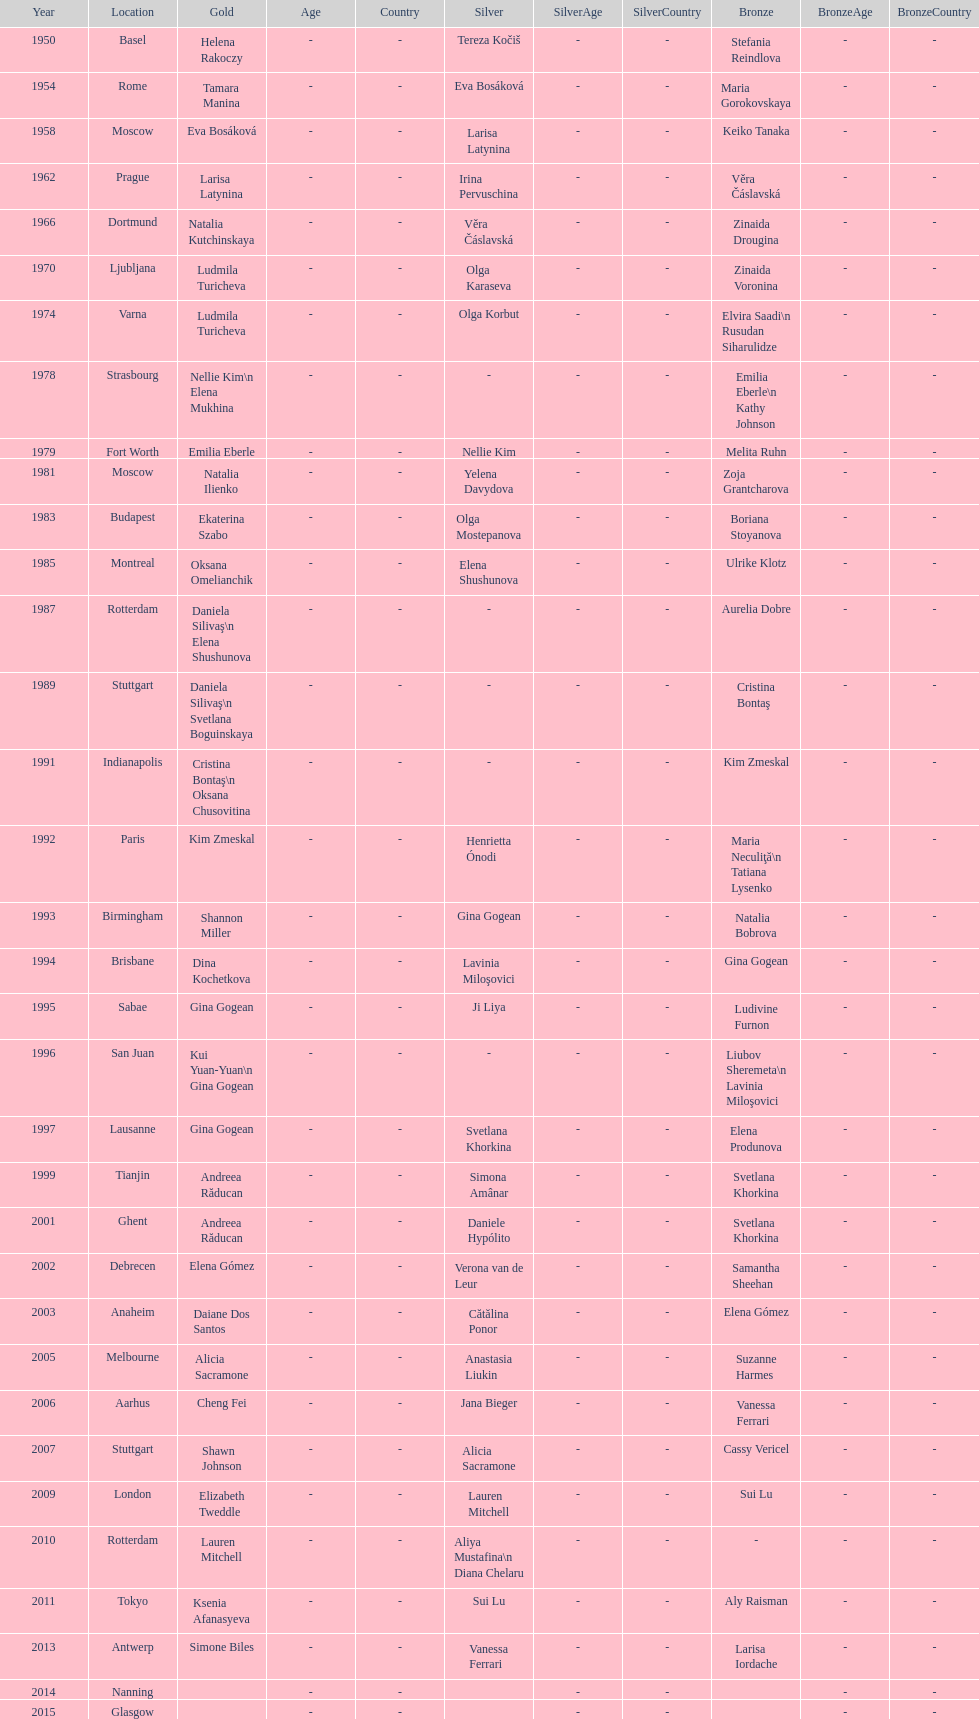Help me parse the entirety of this table. {'header': ['Year', 'Location', 'Gold', 'Age', 'Country', 'Silver', 'SilverAge', 'SilverCountry', 'Bronze', 'BronzeAge', 'BronzeCountry'], 'rows': [['1950', 'Basel', 'Helena Rakoczy', '-', '-', 'Tereza Kočiš', '-', '-', 'Stefania Reindlova', '-', '-'], ['1954', 'Rome', 'Tamara Manina', '-', '-', 'Eva Bosáková', '-', '-', 'Maria Gorokovskaya', '-', '-'], ['1958', 'Moscow', 'Eva Bosáková', '-', '-', 'Larisa Latynina', '-', '-', 'Keiko Tanaka', '-', '-'], ['1962', 'Prague', 'Larisa Latynina', '-', '-', 'Irina Pervuschina', '-', '-', 'Věra Čáslavská', '-', '-'], ['1966', 'Dortmund', 'Natalia Kutchinskaya', '-', '-', 'Věra Čáslavská', '-', '-', 'Zinaida Drougina', '-', '-'], ['1970', 'Ljubljana', 'Ludmila Turicheva', '-', '-', 'Olga Karaseva', '-', '-', 'Zinaida Voronina', '-', '-'], ['1974', 'Varna', 'Ludmila Turicheva', '-', '-', 'Olga Korbut', '-', '-', 'Elvira Saadi\\n Rusudan Siharulidze', '-', '-'], ['1978', 'Strasbourg', 'Nellie Kim\\n Elena Mukhina', '-', '-', '-', '-', '-', 'Emilia Eberle\\n Kathy Johnson', '-', '-'], ['1979', 'Fort Worth', 'Emilia Eberle', '-', '-', 'Nellie Kim', '-', '-', 'Melita Ruhn', '-', '-'], ['1981', 'Moscow', 'Natalia Ilienko', '-', '-', 'Yelena Davydova', '-', '-', 'Zoja Grantcharova', '-', '-'], ['1983', 'Budapest', 'Ekaterina Szabo', '-', '-', 'Olga Mostepanova', '-', '-', 'Boriana Stoyanova', '-', '-'], ['1985', 'Montreal', 'Oksana Omelianchik', '-', '-', 'Elena Shushunova', '-', '-', 'Ulrike Klotz', '-', '-'], ['1987', 'Rotterdam', 'Daniela Silivaş\\n Elena Shushunova', '-', '-', '-', '-', '-', 'Aurelia Dobre', '-', '-'], ['1989', 'Stuttgart', 'Daniela Silivaş\\n Svetlana Boguinskaya', '-', '-', '-', '-', '-', 'Cristina Bontaş', '-', '-'], ['1991', 'Indianapolis', 'Cristina Bontaş\\n Oksana Chusovitina', '-', '-', '-', '-', '-', 'Kim Zmeskal', '-', '-'], ['1992', 'Paris', 'Kim Zmeskal', '-', '-', 'Henrietta Ónodi', '-', '-', 'Maria Neculiţă\\n Tatiana Lysenko', '-', '-'], ['1993', 'Birmingham', 'Shannon Miller', '-', '-', 'Gina Gogean', '-', '-', 'Natalia Bobrova', '-', '-'], ['1994', 'Brisbane', 'Dina Kochetkova', '-', '-', 'Lavinia Miloşovici', '-', '-', 'Gina Gogean', '-', '-'], ['1995', 'Sabae', 'Gina Gogean', '-', '-', 'Ji Liya', '-', '-', 'Ludivine Furnon', '-', '-'], ['1996', 'San Juan', 'Kui Yuan-Yuan\\n Gina Gogean', '-', '-', '-', '-', '-', 'Liubov Sheremeta\\n Lavinia Miloşovici', '-', '-'], ['1997', 'Lausanne', 'Gina Gogean', '-', '-', 'Svetlana Khorkina', '-', '-', 'Elena Produnova', '-', '-'], ['1999', 'Tianjin', 'Andreea Răducan', '-', '-', 'Simona Amânar', '-', '-', 'Svetlana Khorkina', '-', '-'], ['2001', 'Ghent', 'Andreea Răducan', '-', '-', 'Daniele Hypólito', '-', '-', 'Svetlana Khorkina', '-', '-'], ['2002', 'Debrecen', 'Elena Gómez', '-', '-', 'Verona van de Leur', '-', '-', 'Samantha Sheehan', '-', '-'], ['2003', 'Anaheim', 'Daiane Dos Santos', '-', '-', 'Cătălina Ponor', '-', '-', 'Elena Gómez', '-', '-'], ['2005', 'Melbourne', 'Alicia Sacramone', '-', '-', 'Anastasia Liukin', '-', '-', 'Suzanne Harmes', '-', '-'], ['2006', 'Aarhus', 'Cheng Fei', '-', '-', 'Jana Bieger', '-', '-', 'Vanessa Ferrari', '-', '-'], ['2007', 'Stuttgart', 'Shawn Johnson', '-', '-', 'Alicia Sacramone', '-', '-', 'Cassy Vericel', '-', '-'], ['2009', 'London', 'Elizabeth Tweddle', '-', '-', 'Lauren Mitchell', '-', '-', 'Sui Lu', '-', '-'], ['2010', 'Rotterdam', 'Lauren Mitchell', '-', '-', 'Aliya Mustafina\\n Diana Chelaru', '-', '-', '-', '-', '-'], ['2011', 'Tokyo', 'Ksenia Afanasyeva', '-', '-', 'Sui Lu', '-', '-', 'Aly Raisman', '-', '-'], ['2013', 'Antwerp', 'Simone Biles', '-', '-', 'Vanessa Ferrari', '-', '-', 'Larisa Iordache', '-', '-'], ['2014', 'Nanning', '', '-', '-', '', '-', '-', '', '-', '-'], ['2015', 'Glasgow', '', '-', '-', '', '-', '-', '', '-', '-']]} Where were the championships held before the 1962 prague championships? Moscow. 